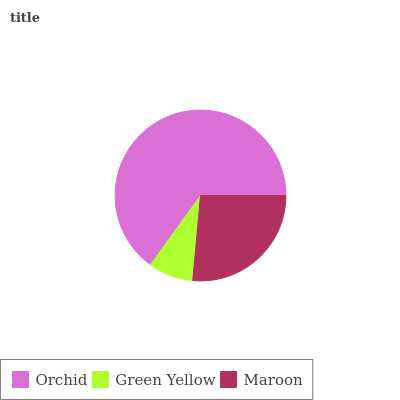Is Green Yellow the minimum?
Answer yes or no. Yes. Is Orchid the maximum?
Answer yes or no. Yes. Is Maroon the minimum?
Answer yes or no. No. Is Maroon the maximum?
Answer yes or no. No. Is Maroon greater than Green Yellow?
Answer yes or no. Yes. Is Green Yellow less than Maroon?
Answer yes or no. Yes. Is Green Yellow greater than Maroon?
Answer yes or no. No. Is Maroon less than Green Yellow?
Answer yes or no. No. Is Maroon the high median?
Answer yes or no. Yes. Is Maroon the low median?
Answer yes or no. Yes. Is Orchid the high median?
Answer yes or no. No. Is Green Yellow the low median?
Answer yes or no. No. 